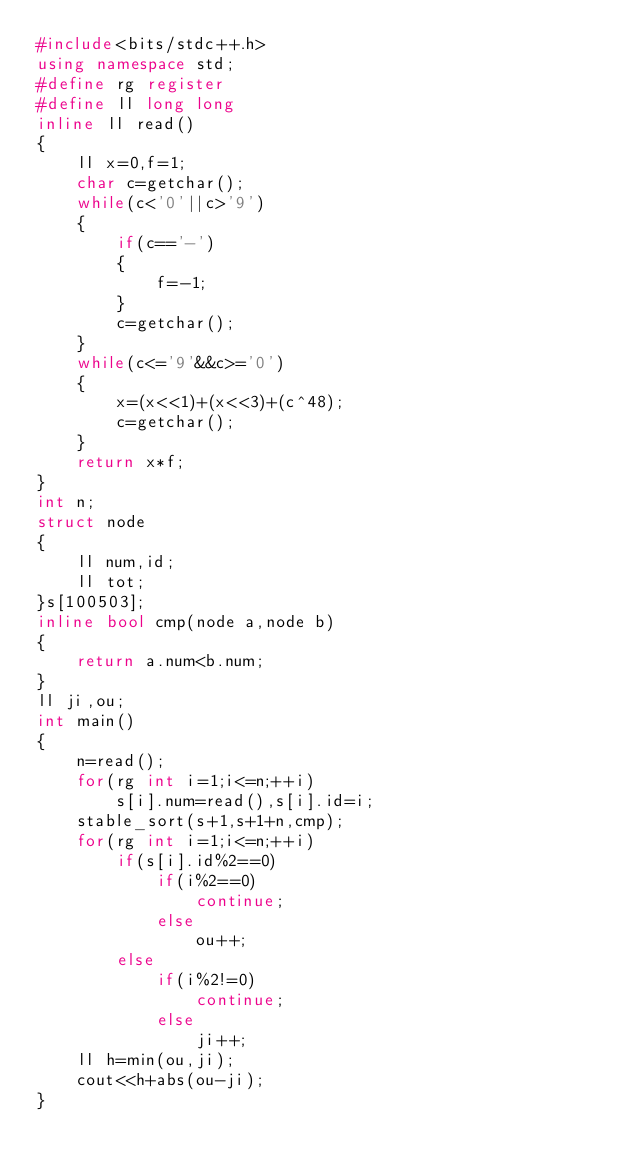Convert code to text. <code><loc_0><loc_0><loc_500><loc_500><_C++_>#include<bits/stdc++.h>
using namespace std;
#define rg register
#define ll long long 
inline ll read()
{
    ll x=0,f=1;
    char c=getchar();
    while(c<'0'||c>'9')
    {
        if(c=='-')
        {
            f=-1;
        }
        c=getchar();
    }
    while(c<='9'&&c>='0')
    {
        x=(x<<1)+(x<<3)+(c^48);
        c=getchar();
    }
    return x*f;
}
int n;
struct node
{
    ll num,id;
    ll tot;
}s[100503];
inline bool cmp(node a,node b)
{
    return a.num<b.num;
}
ll ji,ou;
int main()
{
    n=read();
    for(rg int i=1;i<=n;++i)
        s[i].num=read(),s[i].id=i;
    stable_sort(s+1,s+1+n,cmp);
    for(rg int i=1;i<=n;++i)
        if(s[i].id%2==0)
            if(i%2==0)
                continue;
            else
                ou++;
        else 
            if(i%2!=0)
                continue;
            else
                ji++;
    ll h=min(ou,ji);
    cout<<h+abs(ou-ji);
}</code> 